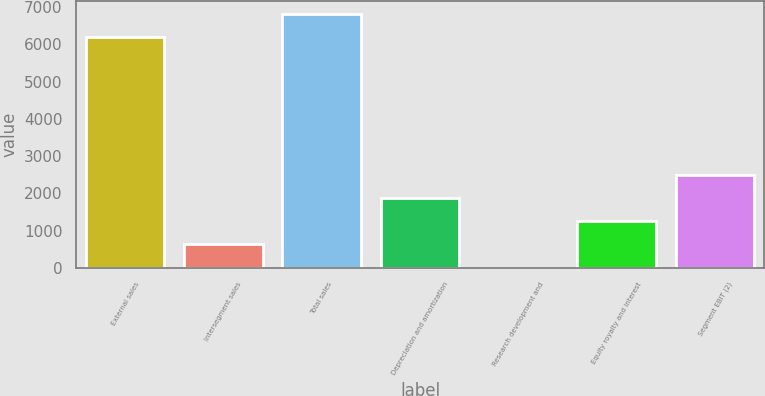Convert chart to OTSL. <chart><loc_0><loc_0><loc_500><loc_500><bar_chart><fcel>External sales<fcel>Intersegment sales<fcel>Total sales<fcel>Depreciation and amortization<fcel>Research development and<fcel>Equity royalty and interest<fcel>Segment EBIT (2)<nl><fcel>6198<fcel>631.9<fcel>6819.9<fcel>1875.7<fcel>10<fcel>1253.8<fcel>2497.6<nl></chart> 